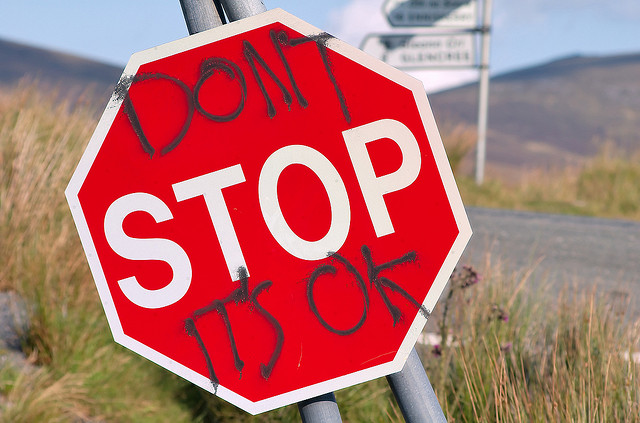Please identify all text content in this image. DONT STOP IT'S OK 